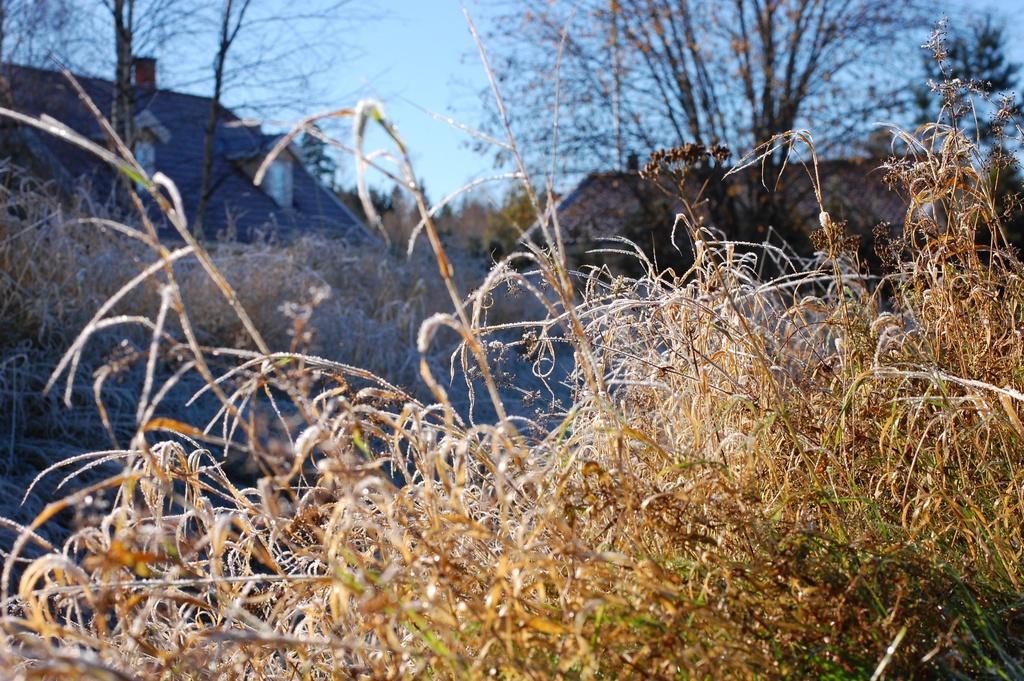In one or two sentences, can you explain what this image depicts? In this picture we can see grass, few houses and trees. 